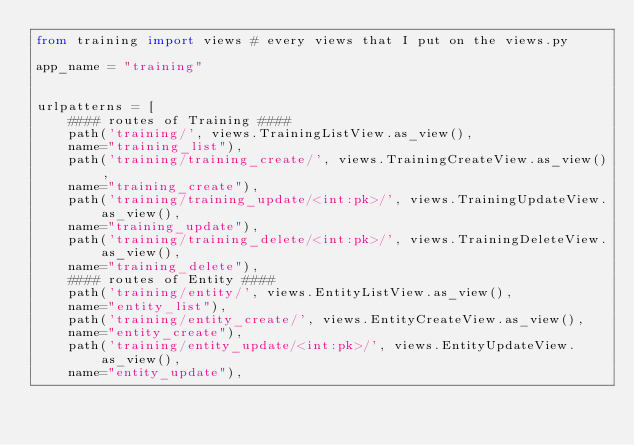Convert code to text. <code><loc_0><loc_0><loc_500><loc_500><_Python_>from training import views # every views that I put on the views.py

app_name = "training"


urlpatterns = [
    #### routes of Training ####
    path('training/', views.TrainingListView.as_view(),
    name="training_list"),
    path('training/training_create/', views.TrainingCreateView.as_view(),
    name="training_create"),
    path('training/training_update/<int:pk>/', views.TrainingUpdateView.as_view(),
    name="training_update"),
    path('training/training_delete/<int:pk>/', views.TrainingDeleteView.as_view(),
    name="training_delete"),
    #### routes of Entity ####
    path('training/entity/', views.EntityListView.as_view(),
    name="entity_list"),
    path('training/entity_create/', views.EntityCreateView.as_view(),
    name="entity_create"),
    path('training/entity_update/<int:pk>/', views.EntityUpdateView.as_view(),
    name="entity_update"),</code> 